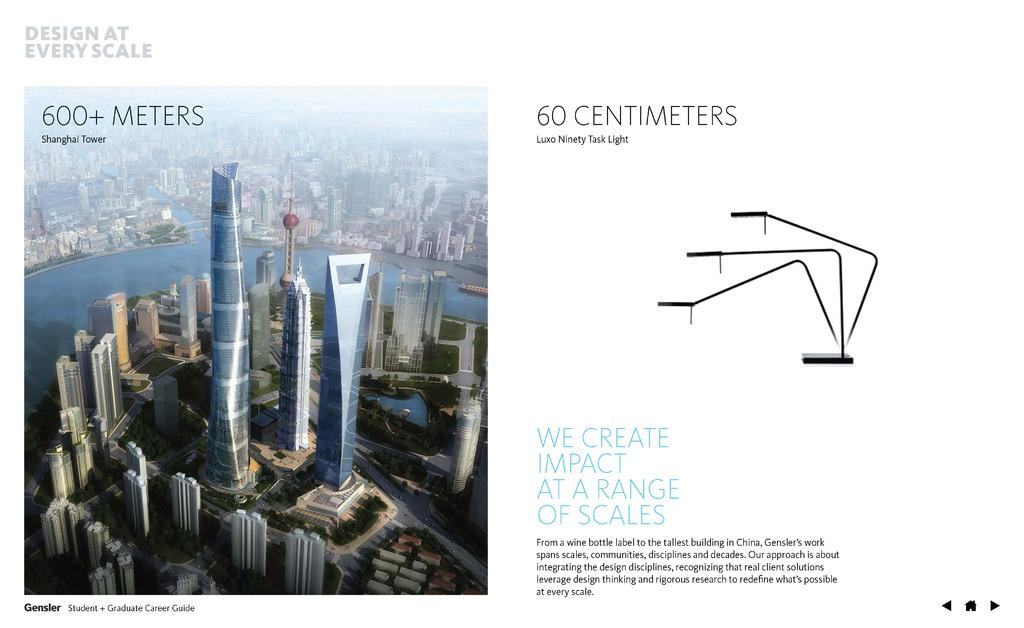What is the main subject of the image? The main subject of the image is a poster. What types of images are on the poster? The poster contains images of buildings and water. What is the stand in the image used for? The stand in the image is likely used to display or hold the poster. What can be found on the poster besides images? There is text written on the poster. What is the color of the background in the image? The background of the image is white. Can you see the father and the moon in the image? There is no father or moon present in the image; it only contains a poster with images of buildings and water, text, and a stand. What type of laborer is depicted in the image? There is no laborer depicted in the image; it only contains a poster with images of buildings and water, text, and a stand. 